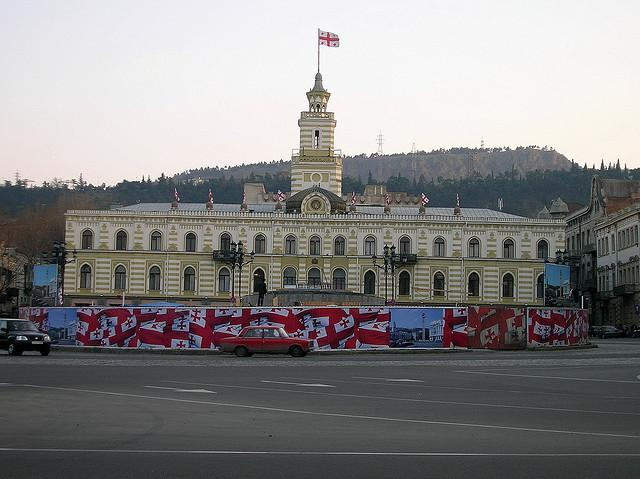This country has what type of government? Please explain your reasoning. republic. The canadian flag is shown. 